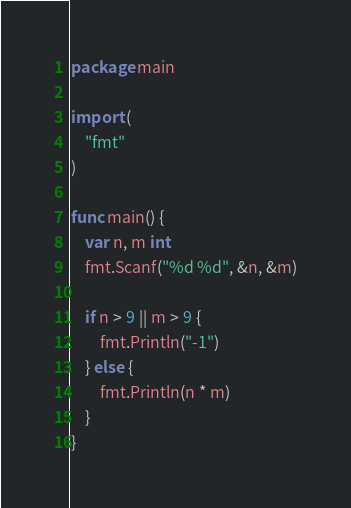Convert code to text. <code><loc_0><loc_0><loc_500><loc_500><_Go_>package main

import (
	"fmt"
)

func main() {
	var n, m int
	fmt.Scanf("%d %d", &n, &m)

	if n > 9 || m > 9 {
		fmt.Println("-1")
	} else {
		fmt.Println(n * m)
	}
}
</code> 